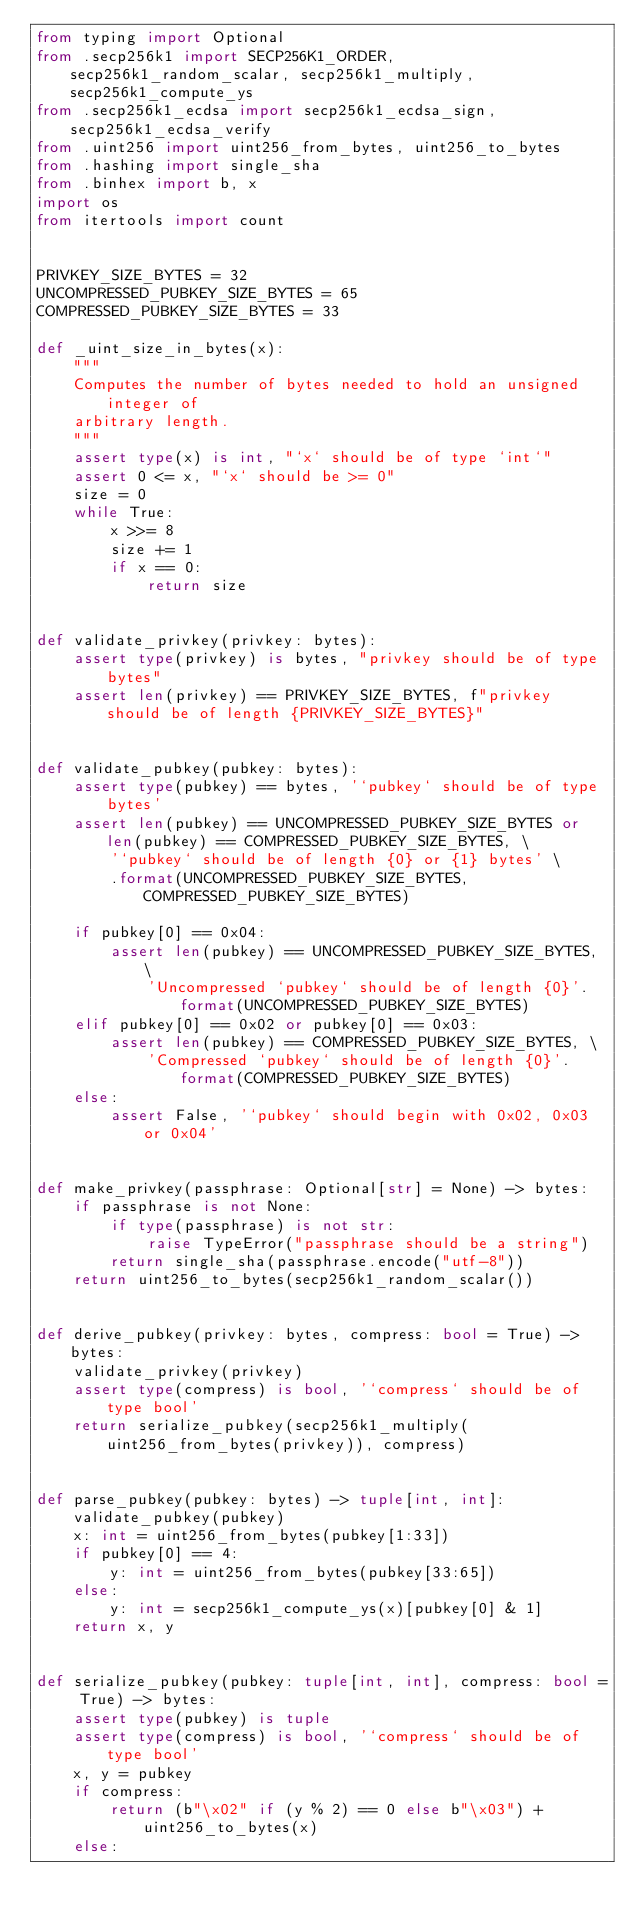Convert code to text. <code><loc_0><loc_0><loc_500><loc_500><_Python_>from typing import Optional
from .secp256k1 import SECP256K1_ORDER, secp256k1_random_scalar, secp256k1_multiply, secp256k1_compute_ys
from .secp256k1_ecdsa import secp256k1_ecdsa_sign, secp256k1_ecdsa_verify
from .uint256 import uint256_from_bytes, uint256_to_bytes
from .hashing import single_sha
from .binhex import b, x
import os
from itertools import count


PRIVKEY_SIZE_BYTES = 32
UNCOMPRESSED_PUBKEY_SIZE_BYTES = 65
COMPRESSED_PUBKEY_SIZE_BYTES = 33

def _uint_size_in_bytes(x):
    """
    Computes the number of bytes needed to hold an unsigned integer of
    arbitrary length. 
    """
    assert type(x) is int, "`x` should be of type `int`"
    assert 0 <= x, "`x` should be >= 0"
    size = 0
    while True:
        x >>= 8
        size += 1
        if x == 0:
            return size  


def validate_privkey(privkey: bytes):
    assert type(privkey) is bytes, "privkey should be of type bytes"
    assert len(privkey) == PRIVKEY_SIZE_BYTES, f"privkey should be of length {PRIVKEY_SIZE_BYTES}"


def validate_pubkey(pubkey: bytes):
    assert type(pubkey) == bytes, '`pubkey` should be of type bytes'
    assert len(pubkey) == UNCOMPRESSED_PUBKEY_SIZE_BYTES or len(pubkey) == COMPRESSED_PUBKEY_SIZE_BYTES, \
        '`pubkey` should be of length {0} or {1} bytes' \
        .format(UNCOMPRESSED_PUBKEY_SIZE_BYTES, COMPRESSED_PUBKEY_SIZE_BYTES)

    if pubkey[0] == 0x04:
        assert len(pubkey) == UNCOMPRESSED_PUBKEY_SIZE_BYTES, \
            'Uncompressed `pubkey` should be of length {0}'.format(UNCOMPRESSED_PUBKEY_SIZE_BYTES)
    elif pubkey[0] == 0x02 or pubkey[0] == 0x03:
        assert len(pubkey) == COMPRESSED_PUBKEY_SIZE_BYTES, \
            'Compressed `pubkey` should be of length {0}'.format(COMPRESSED_PUBKEY_SIZE_BYTES)
    else:
        assert False, '`pubkey` should begin with 0x02, 0x03 or 0x04'


def make_privkey(passphrase: Optional[str] = None) -> bytes:
    if passphrase is not None:
        if type(passphrase) is not str:
            raise TypeError("passphrase should be a string")
        return single_sha(passphrase.encode("utf-8"))
    return uint256_to_bytes(secp256k1_random_scalar())


def derive_pubkey(privkey: bytes, compress: bool = True) -> bytes:
    validate_privkey(privkey)
    assert type(compress) is bool, '`compress` should be of type bool'
    return serialize_pubkey(secp256k1_multiply(uint256_from_bytes(privkey)), compress)


def parse_pubkey(pubkey: bytes) -> tuple[int, int]:
    validate_pubkey(pubkey)
    x: int = uint256_from_bytes(pubkey[1:33])
    if pubkey[0] == 4:
        y: int = uint256_from_bytes(pubkey[33:65])
    else:
        y: int = secp256k1_compute_ys(x)[pubkey[0] & 1]
    return x, y


def serialize_pubkey(pubkey: tuple[int, int], compress: bool = True) -> bytes:
    assert type(pubkey) is tuple
    assert type(compress) is bool, '`compress` should be of type bool'
    x, y = pubkey
    if compress:
        return (b"\x02" if (y % 2) == 0 else b"\x03") + uint256_to_bytes(x)
    else:</code> 